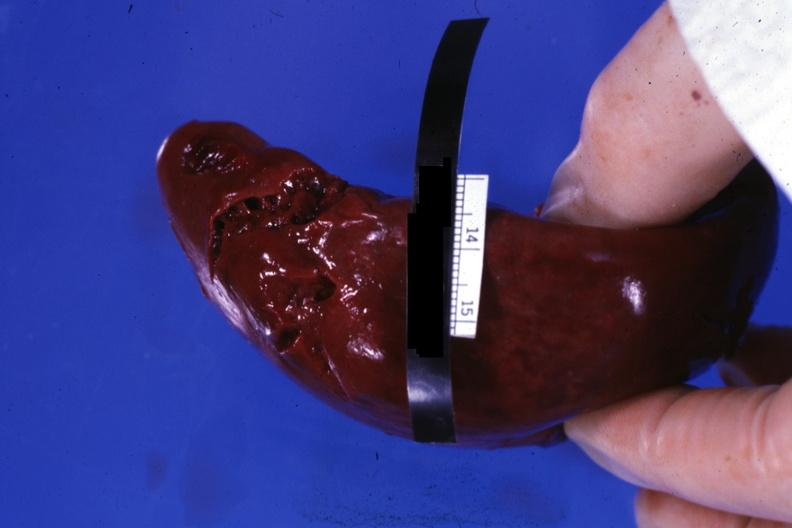does atheromatous embolus show external view of lacerations of capsule apparently done during surgical procedure?
Answer the question using a single word or phrase. No 